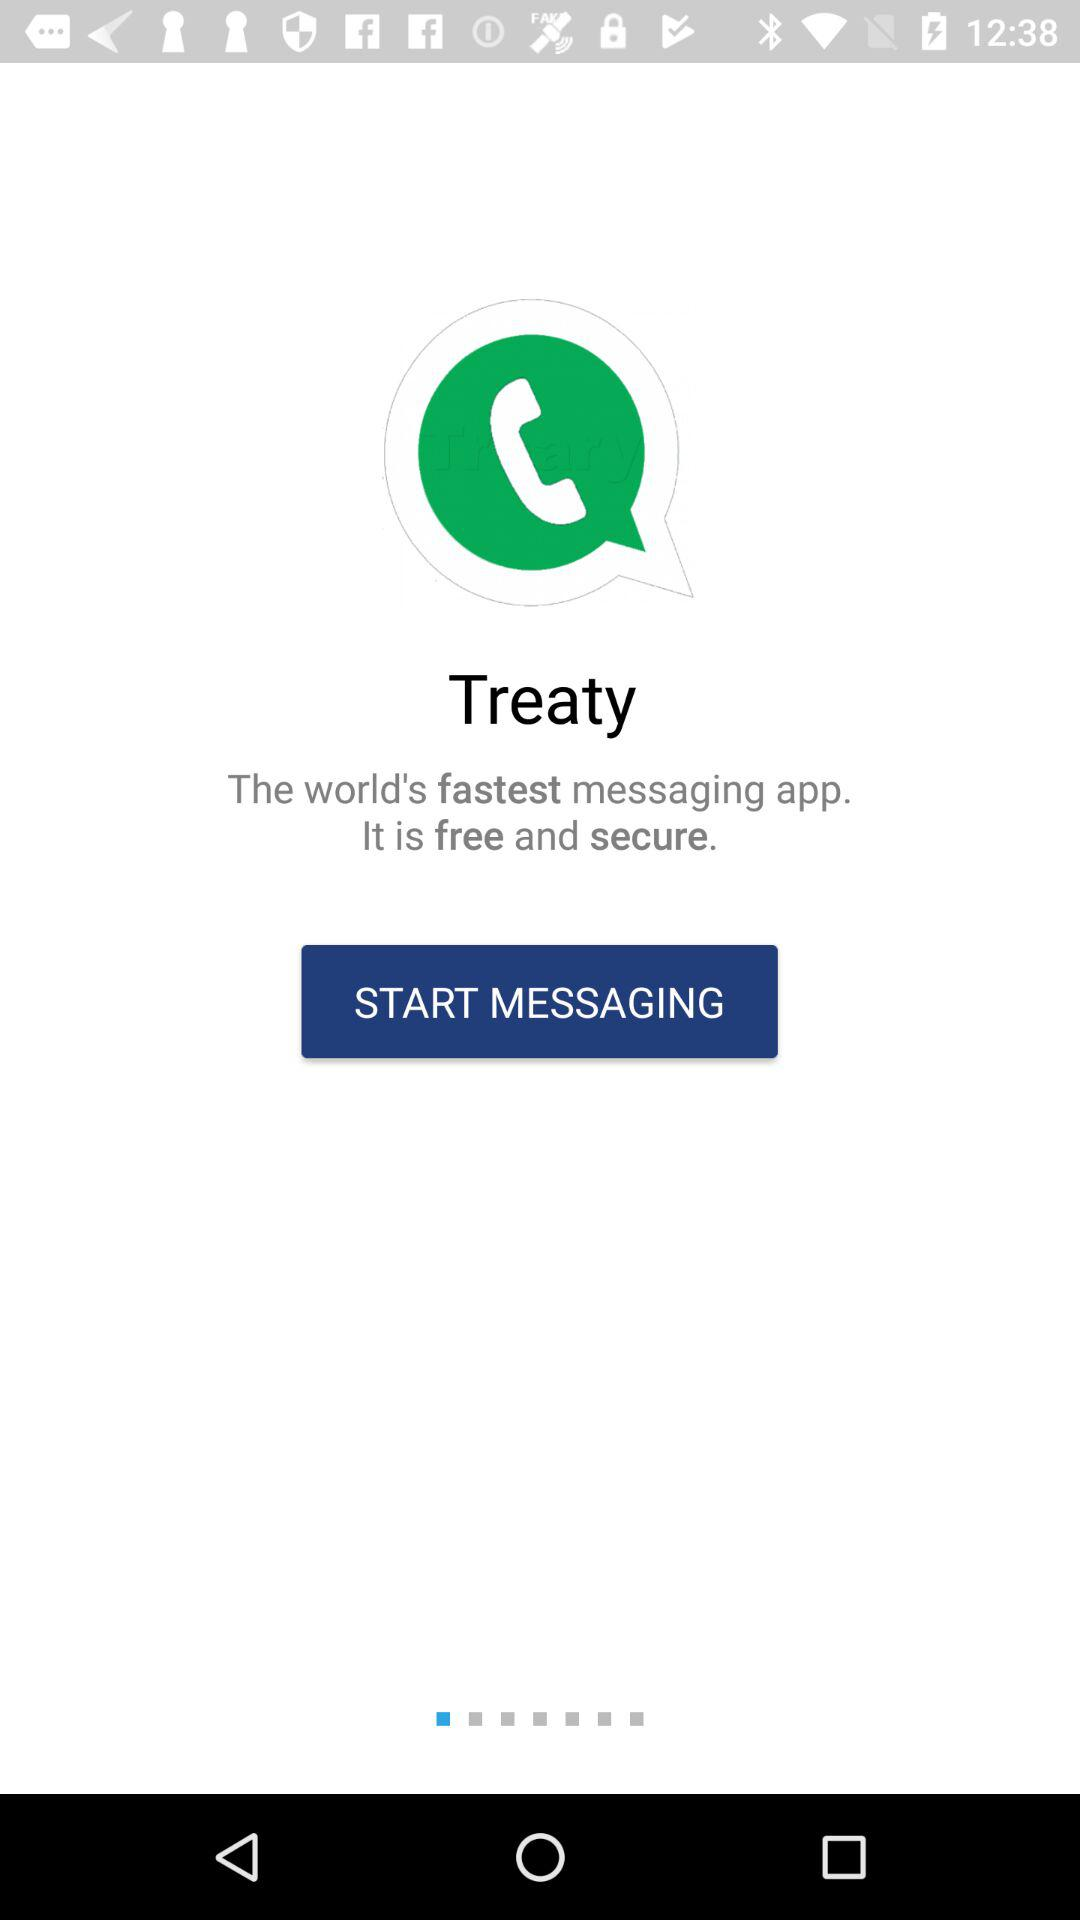What is the name of the application? The name of the application is "Treaty". 